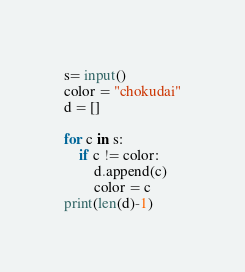Convert code to text. <code><loc_0><loc_0><loc_500><loc_500><_Python_>s= input()
color = "chokudai"
d = []

for c in s:
    if c != color:
        d.append(c)
        color = c
print(len(d)-1)</code> 